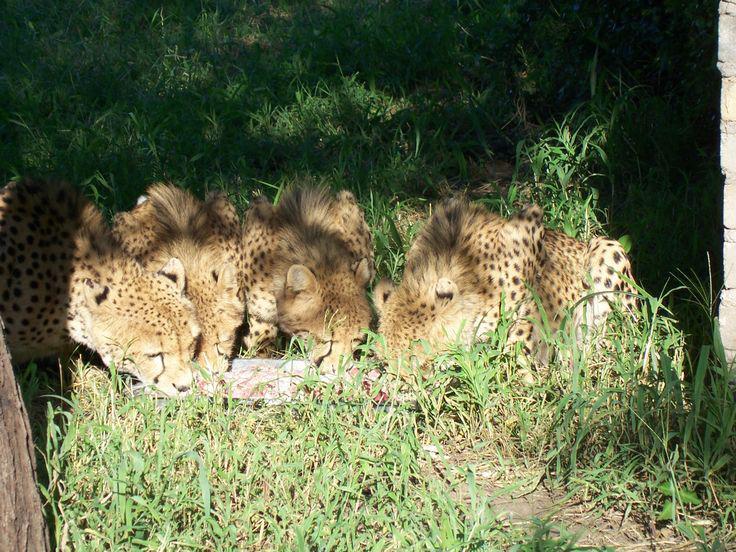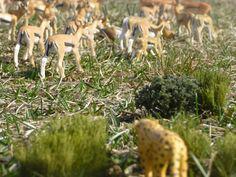The first image is the image on the left, the second image is the image on the right. Considering the images on both sides, is "The right image shows one cheetah capturing a gazelle-type animal, and the left image shows a cheetah crouched behind entrails." valid? Answer yes or no. No. The first image is the image on the left, the second image is the image on the right. Given the left and right images, does the statement "A horned animal is being bitten on the ground by at least one cheetah in the image on the right." hold true? Answer yes or no. No. 